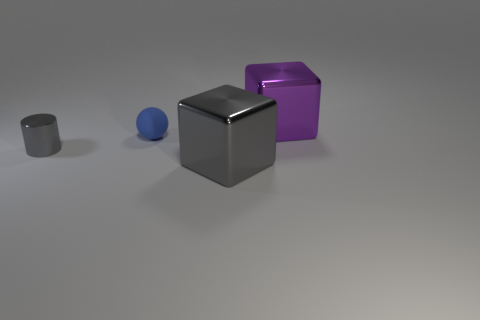Is there anything else that has the same size as the blue object?
Offer a very short reply. Yes. There is another large object that is the same shape as the big gray metal thing; what is it made of?
Keep it short and to the point. Metal. Is there a tiny object that is in front of the big metallic thing that is left of the cube behind the small shiny thing?
Offer a terse response. No. Does the large object that is in front of the small cylinder have the same shape as the large thing behind the blue ball?
Provide a short and direct response. Yes. Are there more gray blocks that are to the left of the small metallic object than large gray balls?
Offer a terse response. No. What number of objects are tiny gray shiny blocks or gray things?
Offer a terse response. 2. What is the color of the cylinder?
Provide a succinct answer. Gray. What number of other objects are the same color as the shiny cylinder?
Make the answer very short. 1. There is a small gray shiny cylinder; are there any cylinders on the left side of it?
Give a very brief answer. No. There is a large cube that is in front of the gray object to the left of the big object in front of the purple cube; what color is it?
Your response must be concise. Gray. 